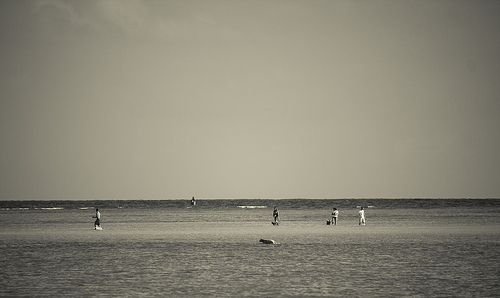[0.53, 0.6, 0.57, 0.66]. This region shows an individual standing stoically on the beach, gazing out towards the horizon over the sea. 